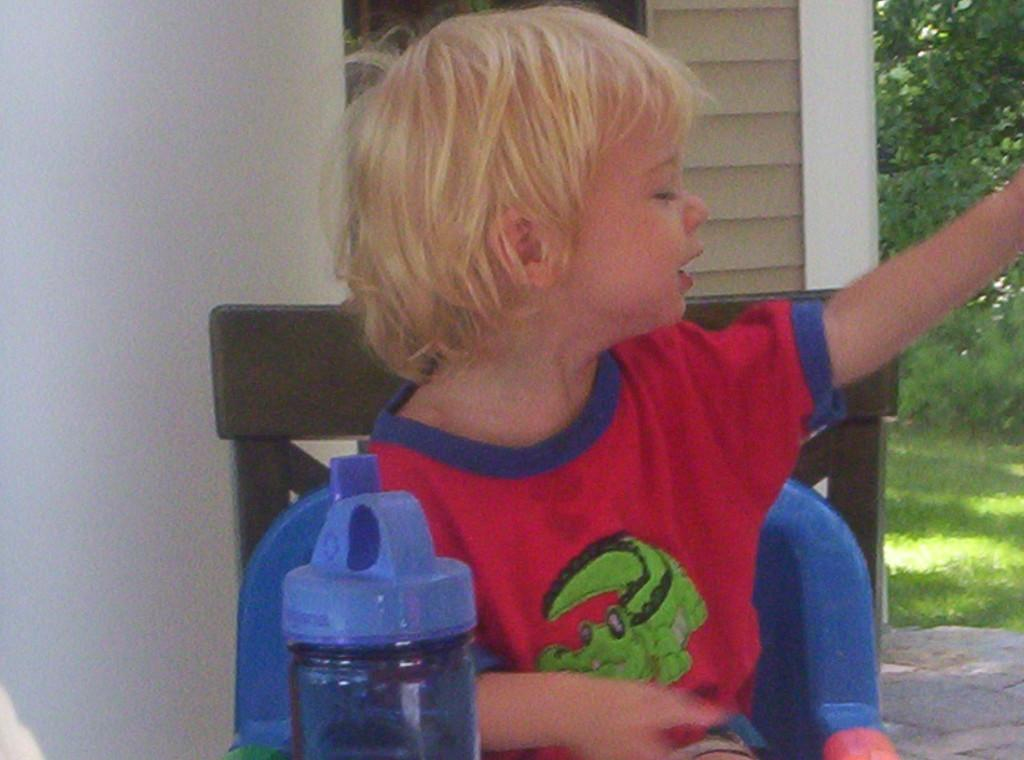What is the kid doing in the image? The kid is sitting on a chair in the image. What object can be seen near the kid? There is a bottle in the image. What can be seen in the background of the image? There is a wall in the background of the image. What type of natural environment is visible in the image? There is grass and trees in the image. What type of pies can be seen flying in the image? There are no pies visible in the image, let alone flying ones. 